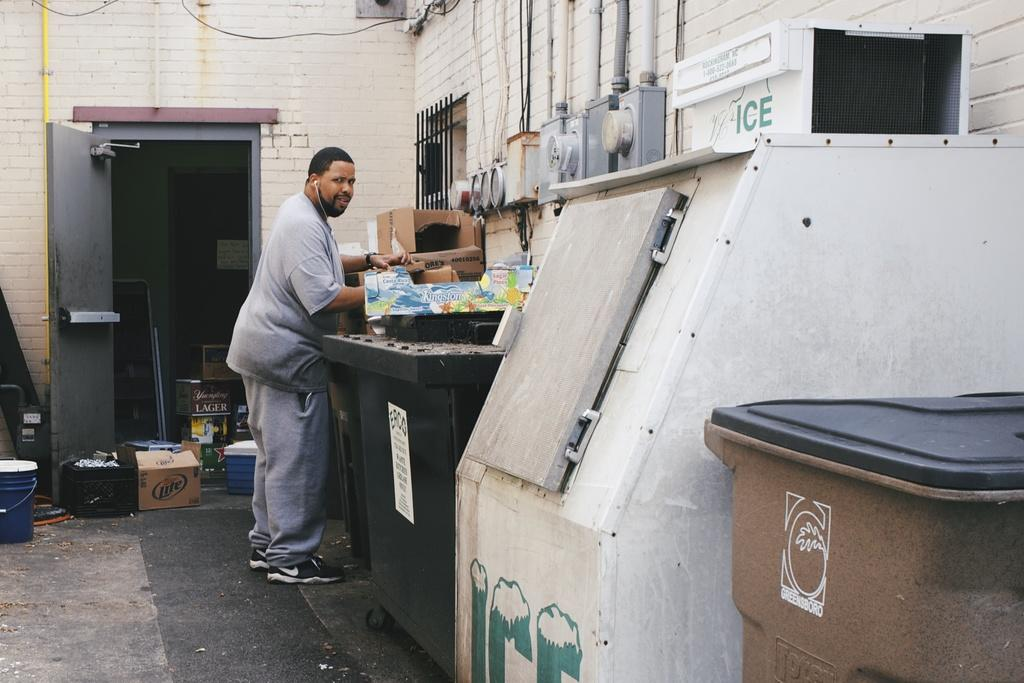Provide a one-sentence caption for the provided image. Man is standing outside looking near a ice machine. 